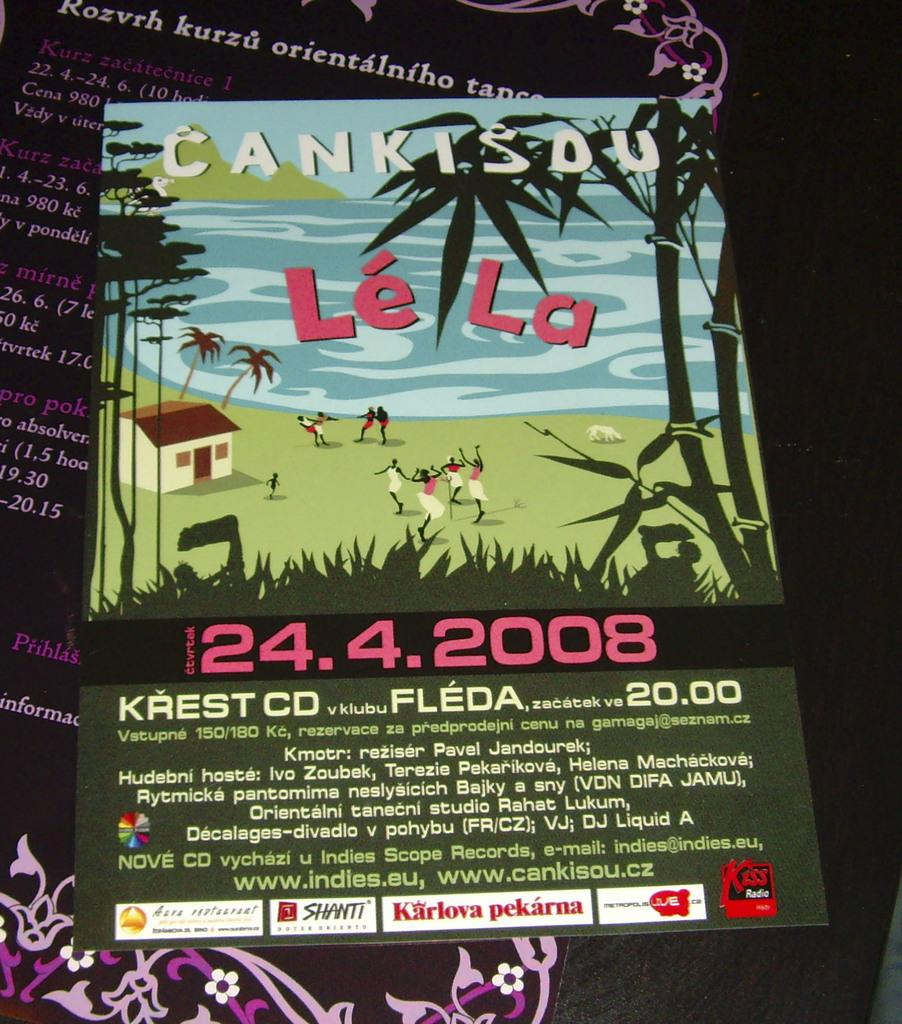<image>
Present a compact description of the photo's key features. A poster advertising an event taking place on April 24 2008. 